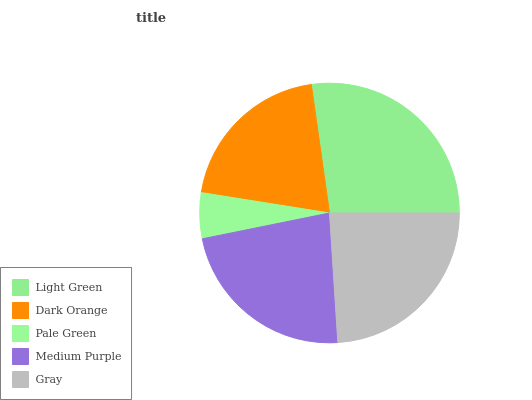Is Pale Green the minimum?
Answer yes or no. Yes. Is Light Green the maximum?
Answer yes or no. Yes. Is Dark Orange the minimum?
Answer yes or no. No. Is Dark Orange the maximum?
Answer yes or no. No. Is Light Green greater than Dark Orange?
Answer yes or no. Yes. Is Dark Orange less than Light Green?
Answer yes or no. Yes. Is Dark Orange greater than Light Green?
Answer yes or no. No. Is Light Green less than Dark Orange?
Answer yes or no. No. Is Medium Purple the high median?
Answer yes or no. Yes. Is Medium Purple the low median?
Answer yes or no. Yes. Is Light Green the high median?
Answer yes or no. No. Is Gray the low median?
Answer yes or no. No. 